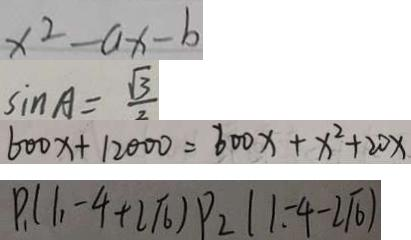Convert formula to latex. <formula><loc_0><loc_0><loc_500><loc_500>x ^ { 2 } - a x - b 
 \sin A = \frac { \sqrt { 3 } } { 2 } 
 6 0 0 x + 1 2 0 0 0 = 6 0 0 x + x ^ { 2 } + 2 0 x 
 P _ { 1 } ( 1 , - 4 + 2 \sqrt { 6 } ) P _ { 2 } ( 1 - 4 - 2 \sqrt { 6 } )</formula> 